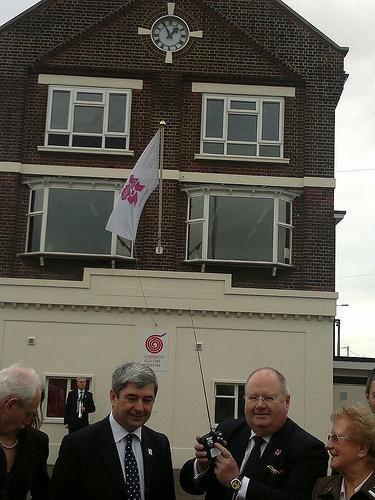How many men are in the picture?
Give a very brief answer. 5. How many women are in the picture?
Give a very brief answer. 2. How many people are wearing glasses?
Give a very brief answer. 2. 